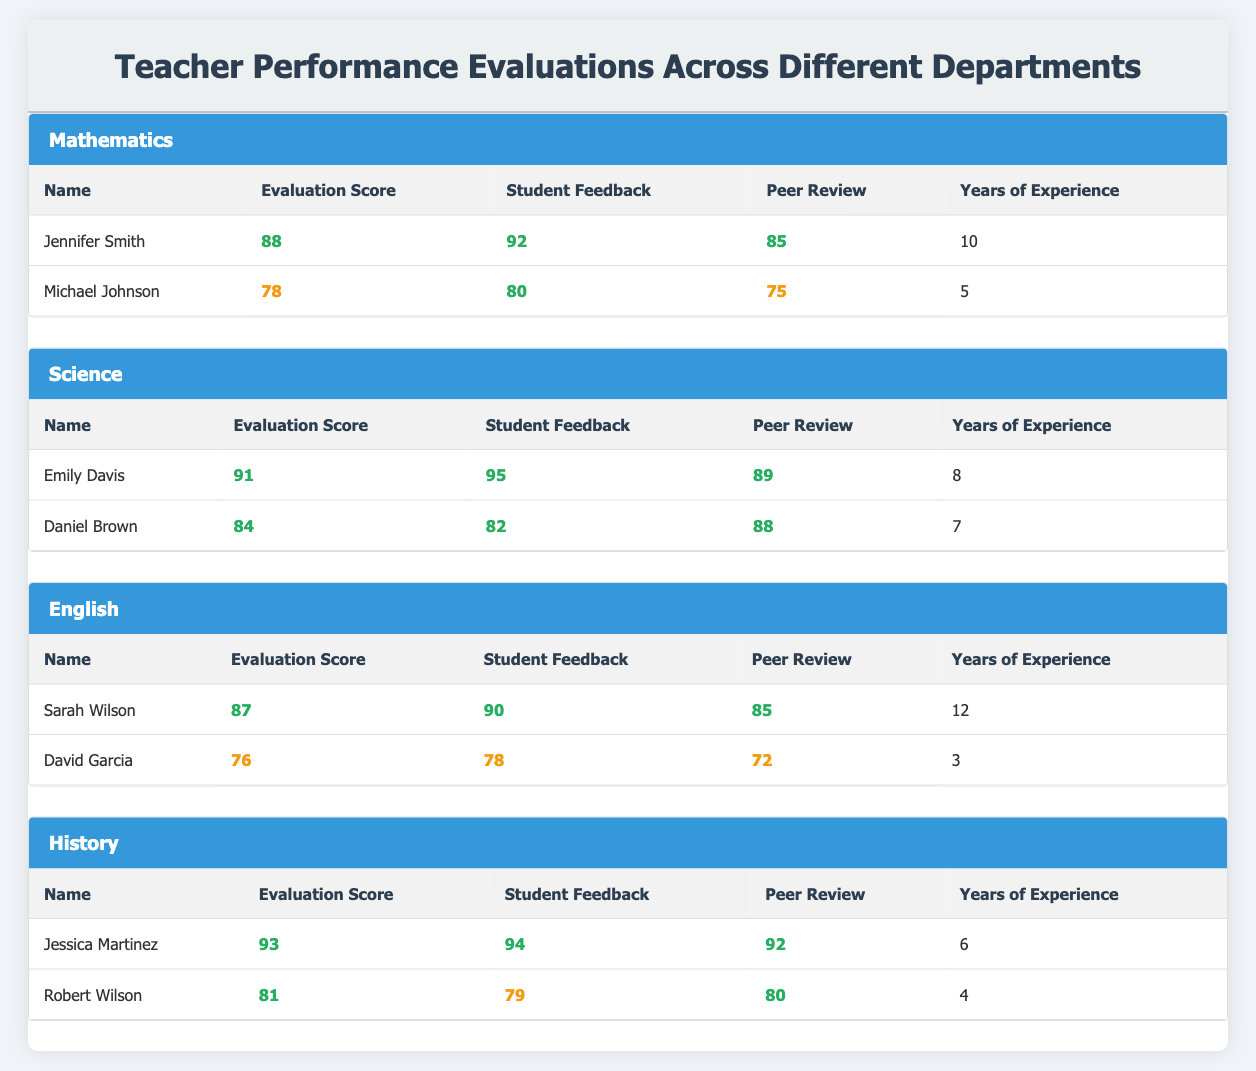What is the Evaluation Score of Emily Davis? The Evaluation Score for Emily Davis is listed in the Science department section of the table. It is explicitly stated as 91.
Answer: 91 Which teacher has the highest Evaluation Score in Mathematics? The table shows that Jennifer Smith has the highest Evaluation Score in Mathematics with a score of 88, compared to Michael Johnson's score of 78.
Answer: Jennifer Smith What is the average Evaluation Score for English teachers? The Evaluation Scores for English teachers are 87 for Sarah Wilson and 76 for David Garcia. Adding these scores (87 + 76 = 163) and dividing by 2 teachers gives an average of 163/2 = 81.5.
Answer: 81.5 Is Daniel Brown's Student Feedback higher than Jessica Martinez's? Daniel Brown has a Student Feedback score of 82, while Jessica Martinez has a score of 94. Since 82 is less than 94, the answer is no.
Answer: No How many years of experience does the teacher with the lowest Evaluation Score have? David Garcia, who has the lowest Evaluation Score of 76 in the English department, has 3 years of experience as listed in the table.
Answer: 3 What is the difference in Evaluation Scores between the highest and lowest performing teachers in History? In History, Jessica Martinez has the highest Evaluation Score of 93, while Robert Wilson has a score of 81. The difference is calculated as 93 - 81 = 12.
Answer: 12 Do both teachers in Science have Evaluation Scores greater than 80? Emily Davis has an Evaluation Score of 91, and Daniel Brown has a score of 84. Both scores are greater than 80, so the answer is yes.
Answer: Yes Which department has the teacher with the highest Student Feedback score? The highest Student Feedback score is given to Emily Davis with a score of 95 in the Science department. Thus, the department with the highest score is Science.
Answer: Science What is the total of Years of Experience for all teachers in the Mathematics department? In the Mathematics department, Jennifer Smith has 10 years and Michael Johnson has 5 years of experience. Adding these gives a total of 10 + 5 = 15 years of experience.
Answer: 15 